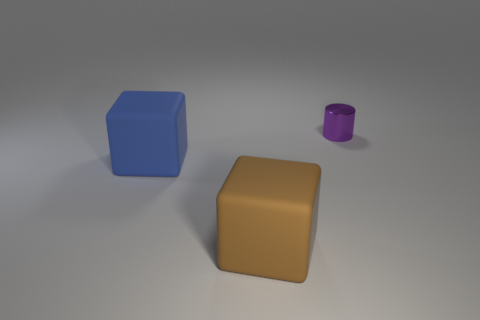The large object in front of the large matte thing on the left side of the object in front of the large blue object is what color? The large object situated in front of the matte surface, to the left of the object that precedes the blue cube, exhibits a rich brown hue. 